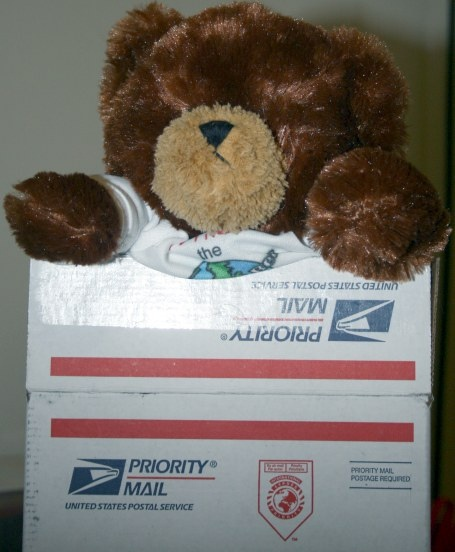Describe the objects in this image and their specific colors. I can see book in gray, darkgray, lightgray, and brown tones and teddy bear in gray, black, maroon, and tan tones in this image. 